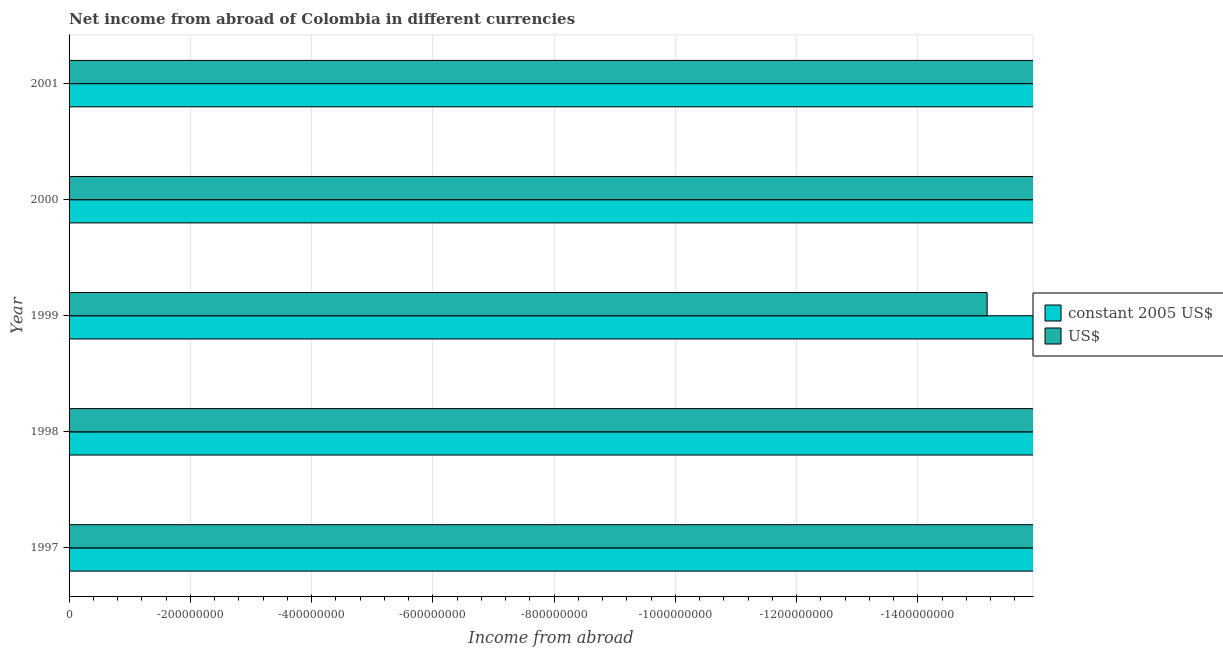How many different coloured bars are there?
Offer a very short reply. 0. Are the number of bars on each tick of the Y-axis equal?
Your answer should be very brief. Yes. How many bars are there on the 2nd tick from the bottom?
Your answer should be compact. 0. In how many cases, is the number of bars for a given year not equal to the number of legend labels?
Your answer should be compact. 5. What is the total income from abroad in us$ in the graph?
Make the answer very short. 0. What is the average income from abroad in us$ per year?
Your answer should be compact. 0. In how many years, is the income from abroad in constant 2005 us$ greater than the average income from abroad in constant 2005 us$ taken over all years?
Keep it short and to the point. 0. How many bars are there?
Provide a short and direct response. 0. Are all the bars in the graph horizontal?
Keep it short and to the point. Yes. How many legend labels are there?
Make the answer very short. 2. How are the legend labels stacked?
Offer a very short reply. Vertical. What is the title of the graph?
Your answer should be very brief. Net income from abroad of Colombia in different currencies. Does "Quasi money growth" appear as one of the legend labels in the graph?
Your response must be concise. No. What is the label or title of the X-axis?
Provide a short and direct response. Income from abroad. What is the Income from abroad in US$ in 1997?
Your response must be concise. 0. What is the Income from abroad in constant 2005 US$ in 1999?
Offer a very short reply. 0. What is the Income from abroad in US$ in 2000?
Offer a terse response. 0. What is the Income from abroad of US$ in 2001?
Ensure brevity in your answer.  0. What is the average Income from abroad in US$ per year?
Provide a succinct answer. 0. 